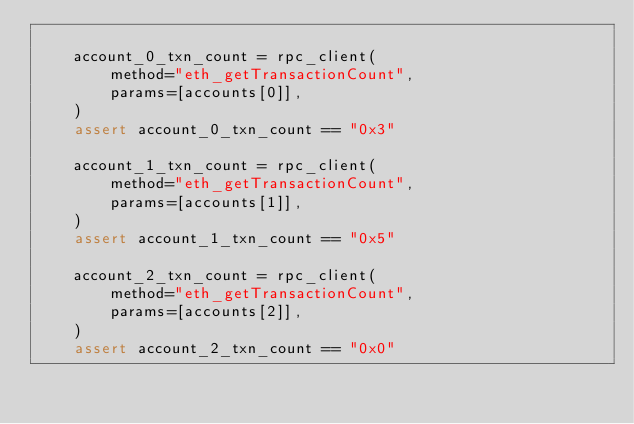Convert code to text. <code><loc_0><loc_0><loc_500><loc_500><_Python_>
    account_0_txn_count = rpc_client(
        method="eth_getTransactionCount",
        params=[accounts[0]],
    )
    assert account_0_txn_count == "0x3"

    account_1_txn_count = rpc_client(
        method="eth_getTransactionCount",
        params=[accounts[1]],
    )
    assert account_1_txn_count == "0x5"

    account_2_txn_count = rpc_client(
        method="eth_getTransactionCount",
        params=[accounts[2]],
    )
    assert account_2_txn_count == "0x0"
</code> 